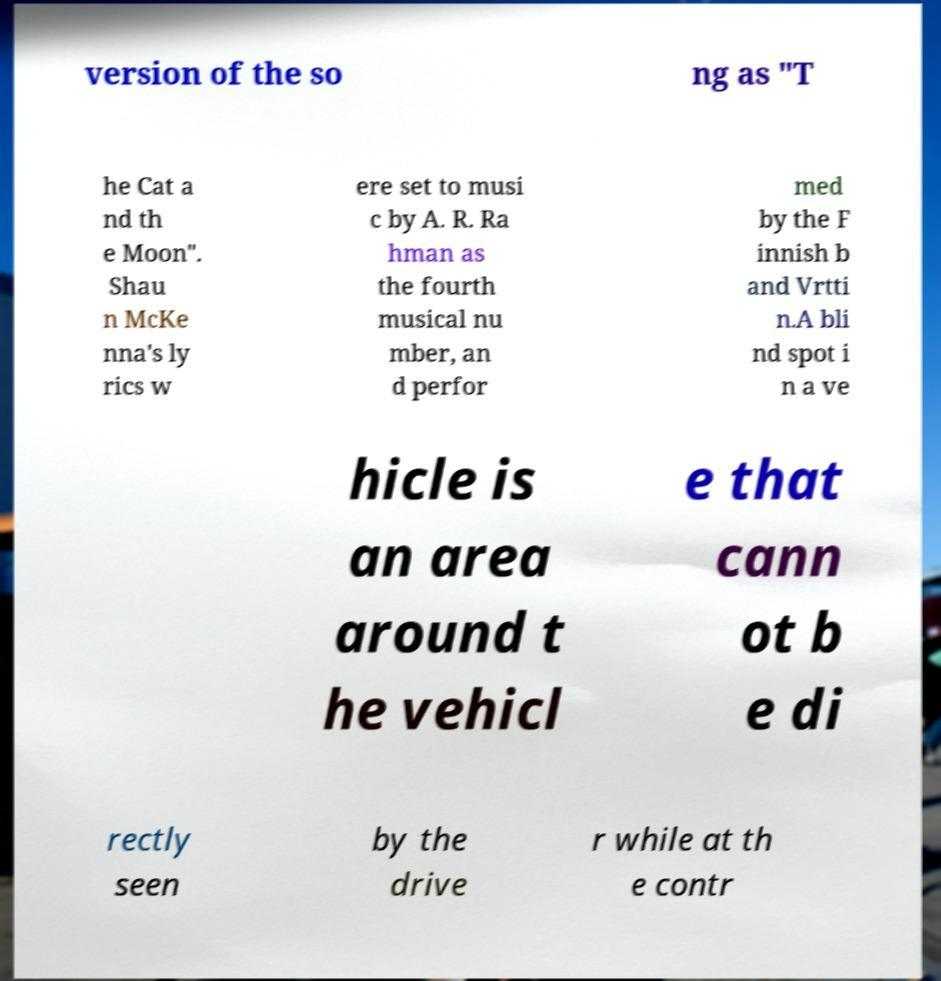I need the written content from this picture converted into text. Can you do that? version of the so ng as "T he Cat a nd th e Moon". Shau n McKe nna's ly rics w ere set to musi c by A. R. Ra hman as the fourth musical nu mber, an d perfor med by the F innish b and Vrtti n.A bli nd spot i n a ve hicle is an area around t he vehicl e that cann ot b e di rectly seen by the drive r while at th e contr 